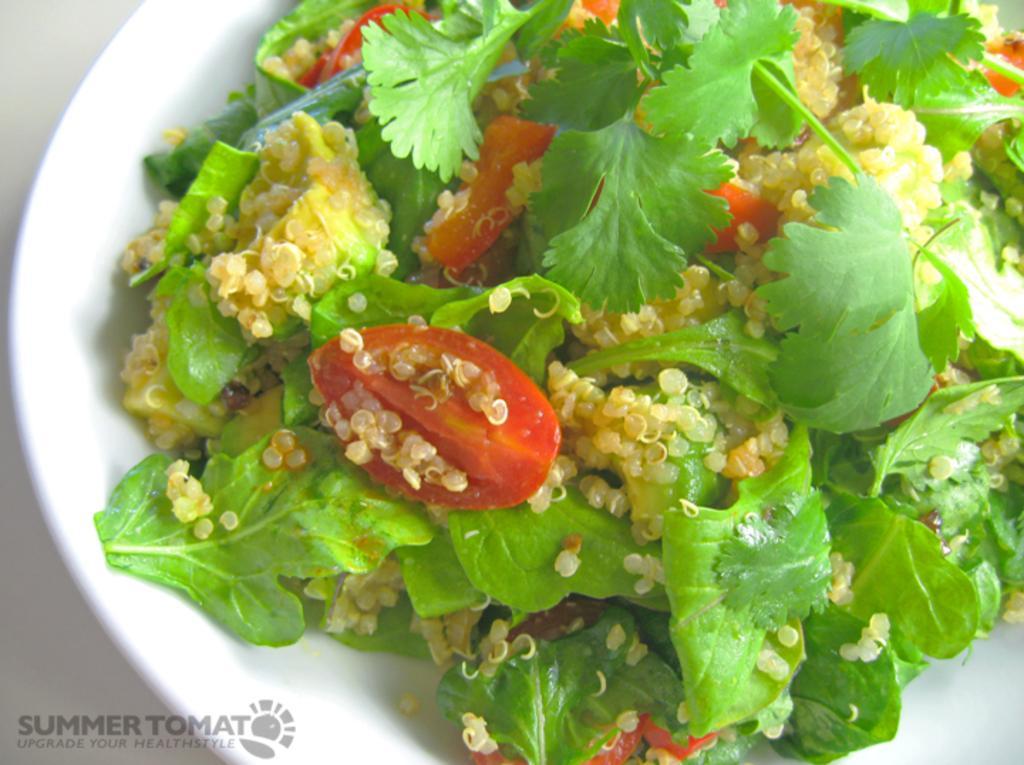Please provide a concise description of this image. In this picture I can see the food in a plate, in the bottom left hand side I can see the watermark. 